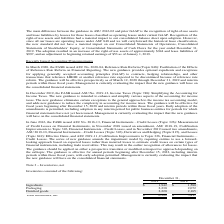According to Lifeway Foods's financial document, What is the value of ingredients in 2019? According to the financial document, 1,942. The relevant text states: "Ingredients $ 1,942 $ 1,580..." Also, What is the value of packaging in 2019? According to the financial document, 2,230. The relevant text states: "Packaging 2,230 2,072..." Also, What is the value of finished goods in 2019? According to the financial document, 2,220. The relevant text states: "Finished goods 2,220 2,165..." Also, can you calculate: What is the percentage change in ingredients between 2018 and 2019? To answer this question, I need to perform calculations using the financial data. The calculation is: (1,942-1,580)/1,580, which equals 22.91 (percentage). This is based on the information: "Ingredients $ 1,942 $ 1,580 Ingredients $ 1,942 $ 1,580..." The key data points involved are: 1,580, 1,942. Also, can you calculate: What is the change in finished goods between 2018 and 2019? Based on the calculation: 2,220-2,165, the result is 55. This is based on the information: "Finished goods 2,220 2,165 Finished goods 2,220 2,165..." The key data points involved are: 2,165, 2,220. Also, can you calculate: What is the average value of packaging for years 2018 and 2019? To answer this question, I need to perform calculations using the financial data. The calculation is: (2,230+2,072)/2, which equals 2151. This is based on the information: "Packaging 2,230 2,072 Packaging 2,230 2,072..." The key data points involved are: 2,072, 2,230. 